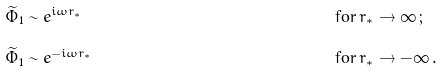Convert formula to latex. <formula><loc_0><loc_0><loc_500><loc_500>\widetilde { \Phi } _ { 1 } & \sim e ^ { i \omega r _ { * } } \, & \text {for} \, & r _ { * } \rightarrow \infty \, ; \\ \widetilde { \Phi } _ { 1 } & \sim e ^ { - i \omega r _ { * } } \, & \text {for} \, & r _ { * } \rightarrow - \infty \, . \\</formula> 